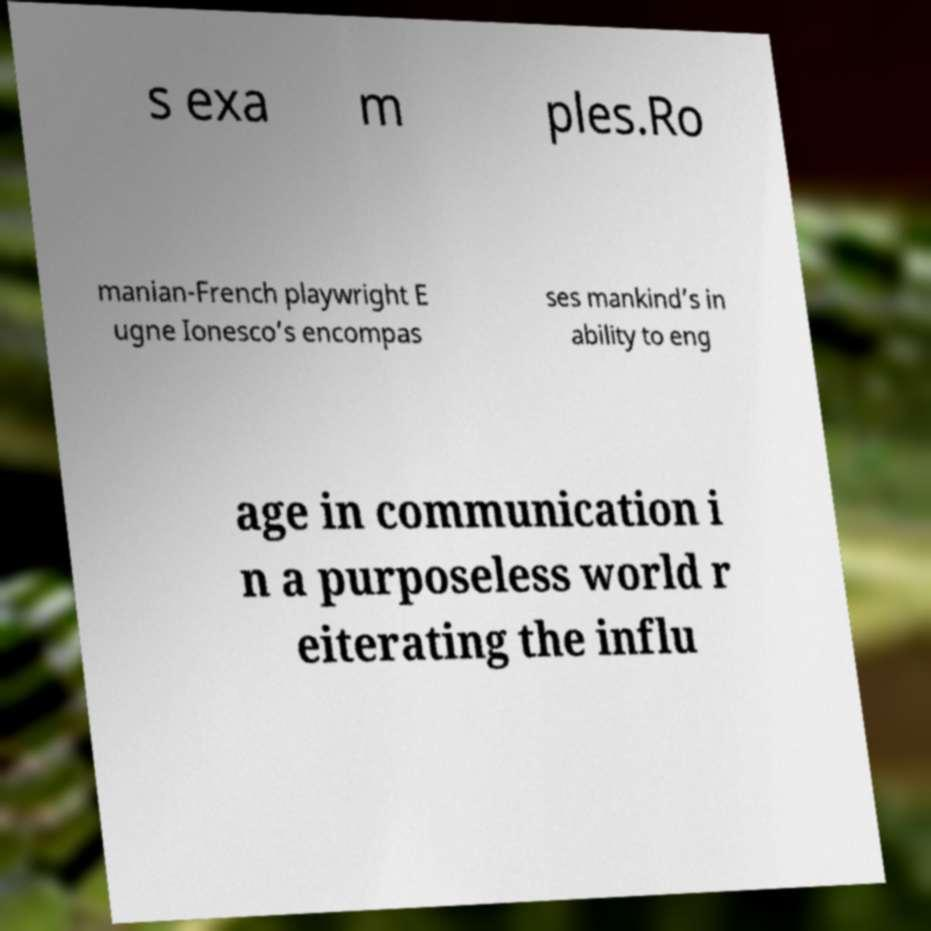I need the written content from this picture converted into text. Can you do that? s exa m ples.Ro manian-French playwright E ugne Ionesco’s encompas ses mankind’s in ability to eng age in communication i n a purposeless world r eiterating the influ 